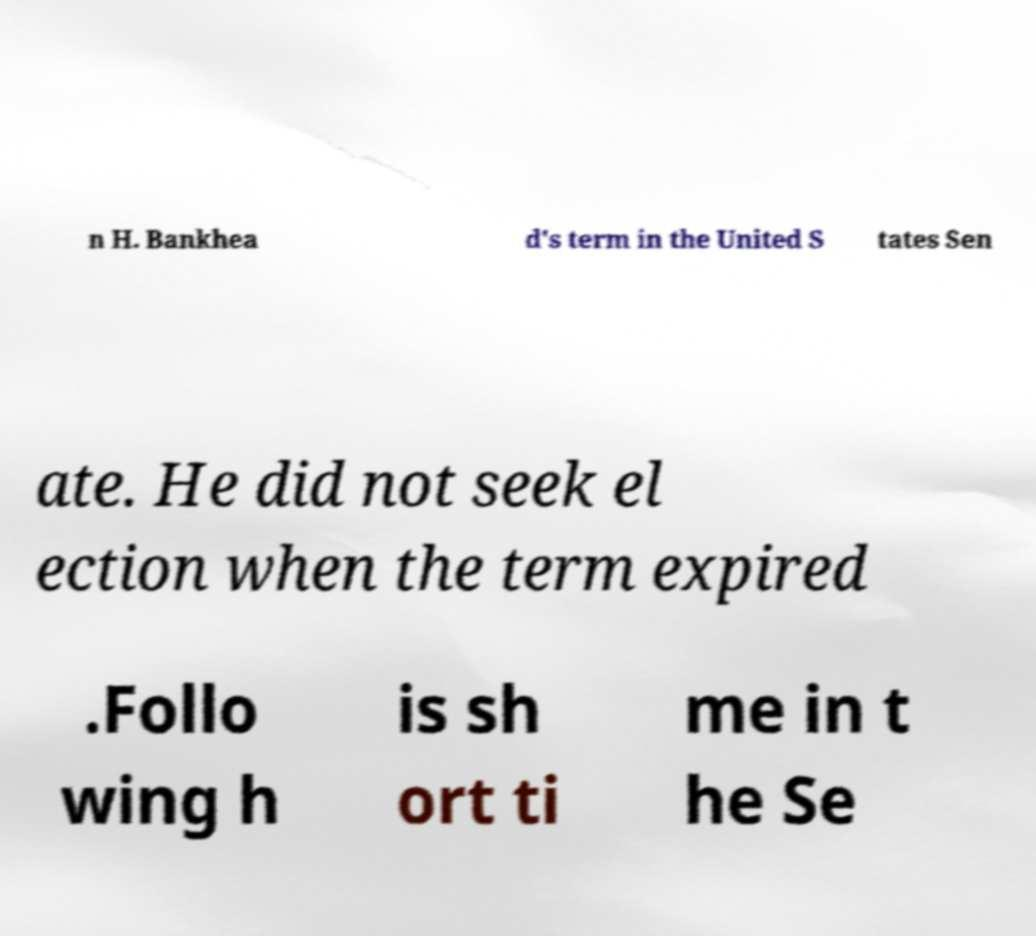Can you read and provide the text displayed in the image?This photo seems to have some interesting text. Can you extract and type it out for me? n H. Bankhea d's term in the United S tates Sen ate. He did not seek el ection when the term expired .Follo wing h is sh ort ti me in t he Se 